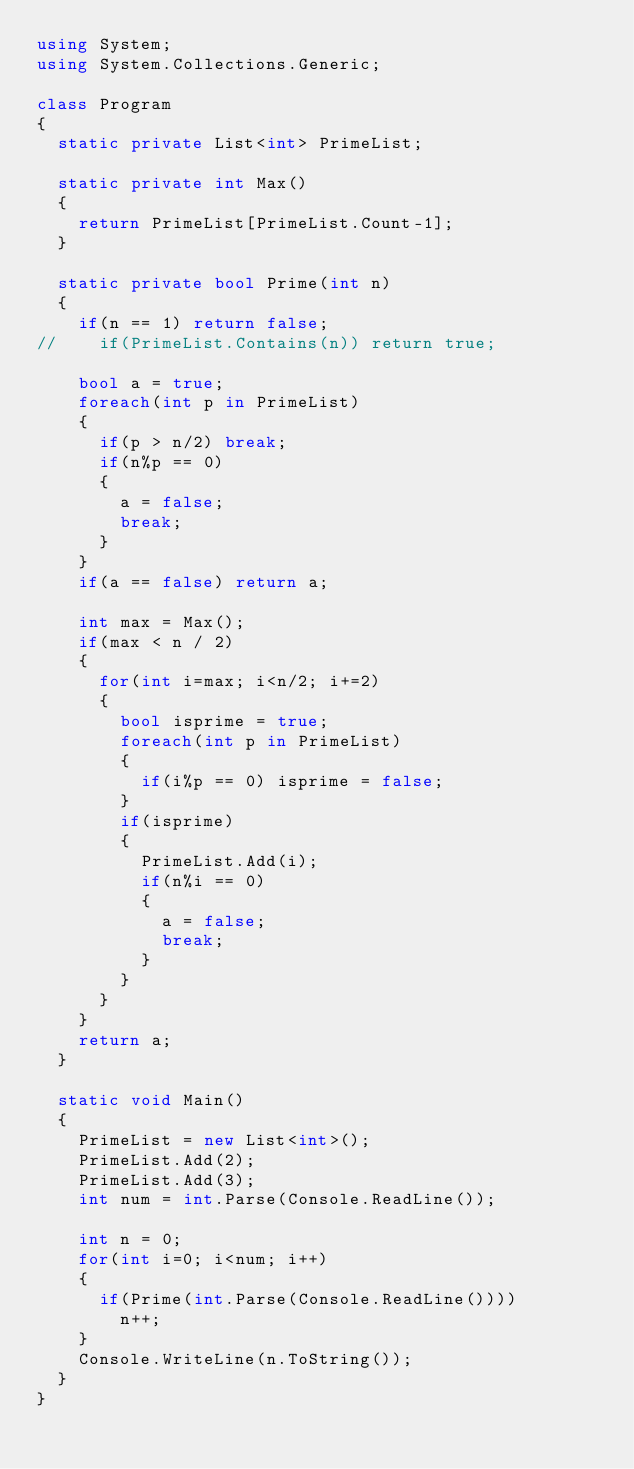<code> <loc_0><loc_0><loc_500><loc_500><_C#_>using System;
using System.Collections.Generic;

class Program
{
	static private List<int> PrimeList;

	static private int Max()
	{
		return PrimeList[PrimeList.Count-1];
	}

	static private bool Prime(int n)
	{
		if(n == 1) return false;
//		if(PrimeList.Contains(n)) return true;

		bool a = true;
		foreach(int p in PrimeList)
		{
			if(p > n/2) break;
			if(n%p == 0)
			{
				a = false;
				break;
			}
		}
		if(a == false) return a;

		int max = Max();
		if(max < n / 2)
		{
			for(int i=max; i<n/2; i+=2)
			{
				bool isprime = true;
				foreach(int p in PrimeList)
				{
					if(i%p == 0) isprime = false;
				}
				if(isprime)
				{
					PrimeList.Add(i);
					if(n%i == 0)
					{
						a = false;
						break;
					}
				}
			}
		}
		return a;
	}

	static void Main() 
	{
		PrimeList = new List<int>();
		PrimeList.Add(2);
		PrimeList.Add(3);
		int num = int.Parse(Console.ReadLine());

		int n = 0;
		for(int i=0; i<num; i++)
		{
			if(Prime(int.Parse(Console.ReadLine())))
				n++;
		}
		Console.WriteLine(n.ToString());
	}
}</code> 